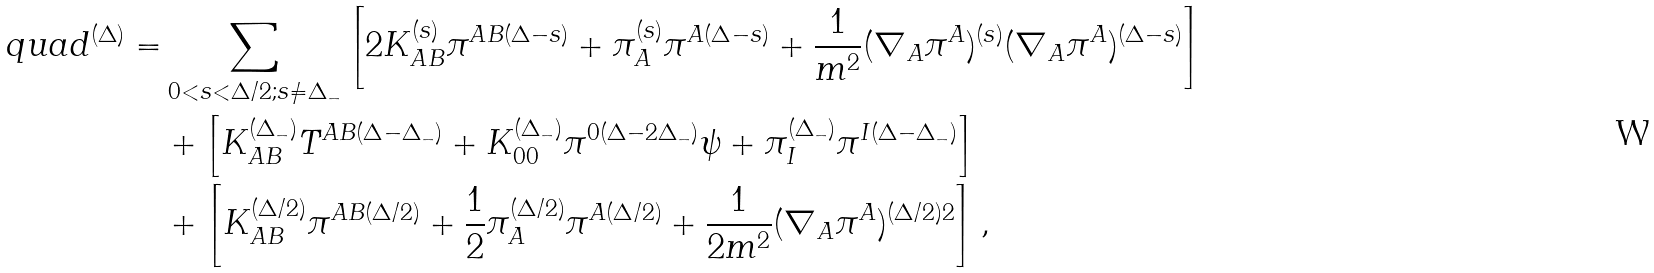<formula> <loc_0><loc_0><loc_500><loc_500>q u a d ^ { ( \Delta ) } = & \sum _ { 0 < s < \Delta / 2 ; s \neq \Delta _ { - } } \left [ 2 K _ { A B } ^ { ( s ) } \pi ^ { A B ( \Delta - s ) } + \pi _ { A } ^ { ( s ) } \pi ^ { A ( \Delta - s ) } + \frac { 1 } { m ^ { 2 } } ( \nabla _ { A } \pi ^ { A } ) ^ { ( s ) } ( \nabla _ { A } \pi ^ { A } ) ^ { ( \Delta - s ) } \right ] \\ & + \left [ K _ { A B } ^ { ( \Delta _ { - } ) } T ^ { A B ( \Delta - \Delta _ { - } ) } + K _ { 0 0 } ^ { ( \Delta _ { - } ) } \pi ^ { 0 ( \Delta - 2 \Delta _ { - } ) } \psi + \pi _ { I } ^ { ( \Delta _ { - } ) } \pi ^ { I ( \Delta - \Delta _ { - } ) } \right ] \\ & + \left [ K _ { A B } ^ { ( \Delta / 2 ) } \pi ^ { A B ( \Delta / 2 ) } + \frac { 1 } { 2 } \pi _ { A } ^ { ( \Delta / 2 ) } \pi ^ { A ( \Delta / 2 ) } + \frac { 1 } { 2 m ^ { 2 } } ( \nabla _ { A } \pi ^ { A } ) ^ { ( \Delta / 2 ) 2 } \right ] ,</formula> 